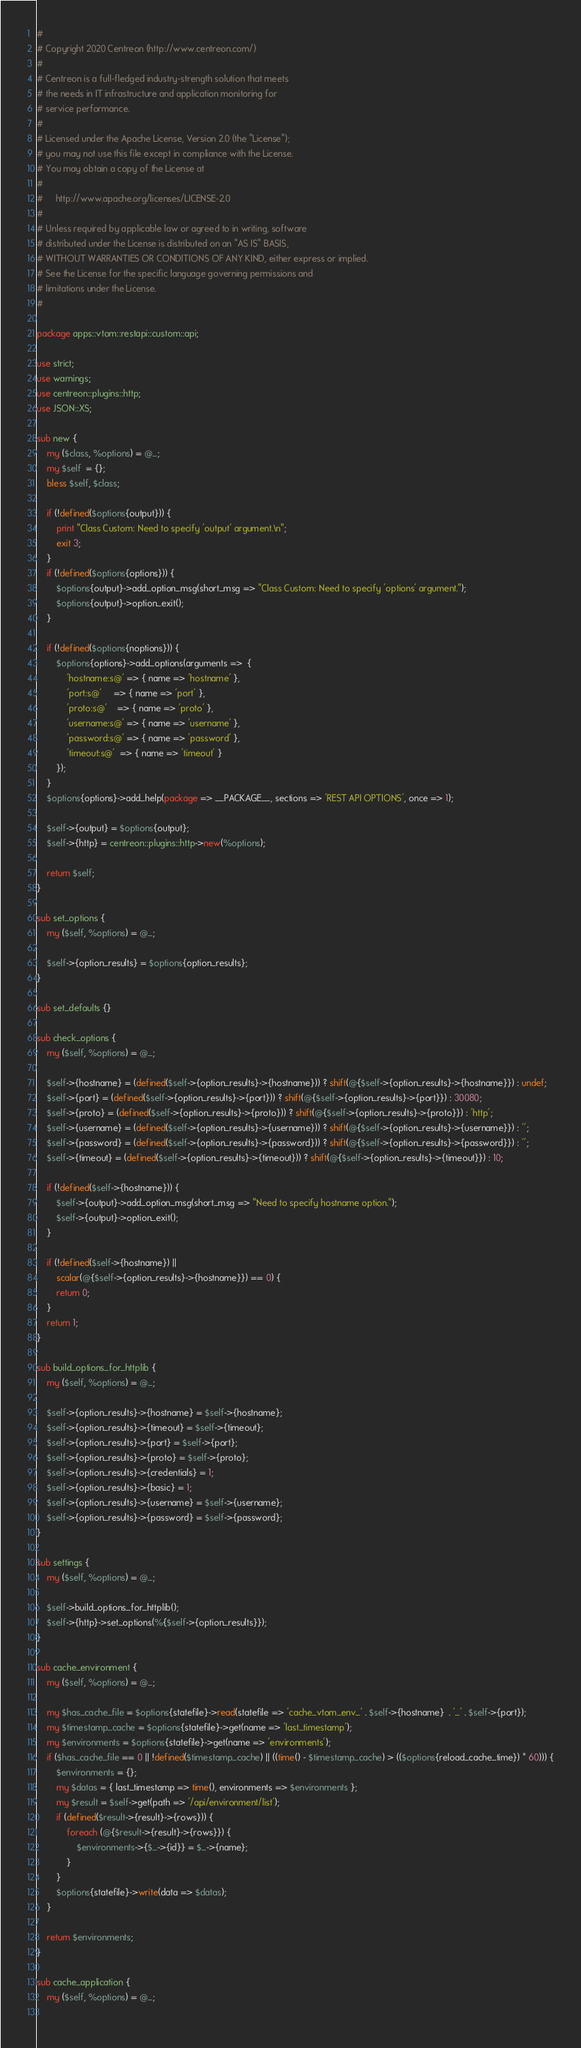Convert code to text. <code><loc_0><loc_0><loc_500><loc_500><_Perl_>#
# Copyright 2020 Centreon (http://www.centreon.com/)
#
# Centreon is a full-fledged industry-strength solution that meets
# the needs in IT infrastructure and application monitoring for
# service performance.
#
# Licensed under the Apache License, Version 2.0 (the "License");
# you may not use this file except in compliance with the License.
# You may obtain a copy of the License at
#
#     http://www.apache.org/licenses/LICENSE-2.0
#
# Unless required by applicable law or agreed to in writing, software
# distributed under the License is distributed on an "AS IS" BASIS,
# WITHOUT WARRANTIES OR CONDITIONS OF ANY KIND, either express or implied.
# See the License for the specific language governing permissions and
# limitations under the License.
#

package apps::vtom::restapi::custom::api;

use strict;
use warnings;
use centreon::plugins::http;
use JSON::XS;

sub new {
    my ($class, %options) = @_;
    my $self  = {};
    bless $self, $class;

    if (!defined($options{output})) {
        print "Class Custom: Need to specify 'output' argument.\n";
        exit 3;
    }
    if (!defined($options{options})) {
        $options{output}->add_option_msg(short_msg => "Class Custom: Need to specify 'options' argument.");
        $options{output}->option_exit();
    }
    
    if (!defined($options{noptions})) {
        $options{options}->add_options(arguments =>  {
            'hostname:s@' => { name => 'hostname' },
            'port:s@'     => { name => 'port' },
            'proto:s@'    => { name => 'proto' },
            'username:s@' => { name => 'username' },
            'password:s@' => { name => 'password' },
            'timeout:s@'  => { name => 'timeout' }
        });
    }
    $options{options}->add_help(package => __PACKAGE__, sections => 'REST API OPTIONS', once => 1);

    $self->{output} = $options{output};
    $self->{http} = centreon::plugins::http->new(%options);

    return $self;
}

sub set_options {
    my ($self, %options) = @_;

    $self->{option_results} = $options{option_results};
}

sub set_defaults {}

sub check_options {
    my ($self, %options) = @_;

    $self->{hostname} = (defined($self->{option_results}->{hostname})) ? shift(@{$self->{option_results}->{hostname}}) : undef;
    $self->{port} = (defined($self->{option_results}->{port})) ? shift(@{$self->{option_results}->{port}}) : 30080;
    $self->{proto} = (defined($self->{option_results}->{proto})) ? shift(@{$self->{option_results}->{proto}}) : 'http';
    $self->{username} = (defined($self->{option_results}->{username})) ? shift(@{$self->{option_results}->{username}}) : '';
    $self->{password} = (defined($self->{option_results}->{password})) ? shift(@{$self->{option_results}->{password}}) : '';
    $self->{timeout} = (defined($self->{option_results}->{timeout})) ? shift(@{$self->{option_results}->{timeout}}) : 10;
 
    if (!defined($self->{hostname})) {
        $self->{output}->add_option_msg(short_msg => "Need to specify hostname option.");
        $self->{output}->option_exit();
    }

    if (!defined($self->{hostname}) ||
        scalar(@{$self->{option_results}->{hostname}}) == 0) {
        return 0;
    }
    return 1;
}

sub build_options_for_httplib {
    my ($self, %options) = @_;

    $self->{option_results}->{hostname} = $self->{hostname};
    $self->{option_results}->{timeout} = $self->{timeout};
    $self->{option_results}->{port} = $self->{port};
    $self->{option_results}->{proto} = $self->{proto};
    $self->{option_results}->{credentials} = 1;
    $self->{option_results}->{basic} = 1;
    $self->{option_results}->{username} = $self->{username};
    $self->{option_results}->{password} = $self->{password};
}

sub settings {
    my ($self, %options) = @_;

    $self->build_options_for_httplib();
    $self->{http}->set_options(%{$self->{option_results}});
}

sub cache_environment {
    my ($self, %options) = @_;
    
    my $has_cache_file = $options{statefile}->read(statefile => 'cache_vtom_env_' . $self->{hostname}  . '_' . $self->{port});
    my $timestamp_cache = $options{statefile}->get(name => 'last_timestamp');
    my $environments = $options{statefile}->get(name => 'environments');
    if ($has_cache_file == 0 || !defined($timestamp_cache) || ((time() - $timestamp_cache) > (($options{reload_cache_time}) * 60))) {
        $environments = {};
        my $datas = { last_timestamp => time(), environments => $environments };
        my $result = $self->get(path => '/api/environment/list');
        if (defined($result->{result}->{rows})) {
            foreach (@{$result->{result}->{rows}}) {
                $environments->{$_->{id}} = $_->{name};
            }
        }
        $options{statefile}->write(data => $datas);
    }
    
    return $environments;
}

sub cache_application {
    my ($self, %options) = @_;
    </code> 